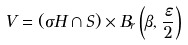<formula> <loc_0><loc_0><loc_500><loc_500>V = ( \sigma H \cap S ) \times B _ { r } \left ( \beta , \frac { \varepsilon } { 2 } \right )</formula> 